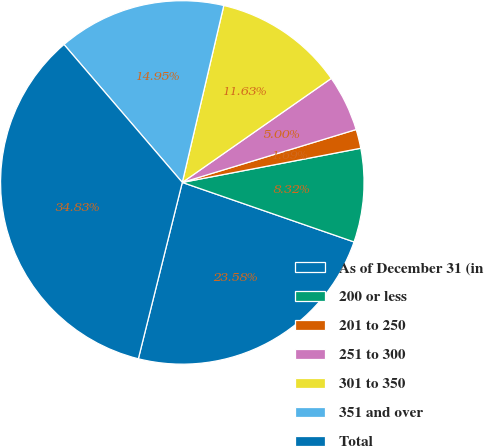<chart> <loc_0><loc_0><loc_500><loc_500><pie_chart><fcel>As of December 31 (in<fcel>200 or less<fcel>201 to 250<fcel>251 to 300<fcel>301 to 350<fcel>351 and over<fcel>Total<nl><fcel>23.58%<fcel>8.32%<fcel>1.69%<fcel>5.0%<fcel>11.63%<fcel>14.95%<fcel>34.83%<nl></chart> 